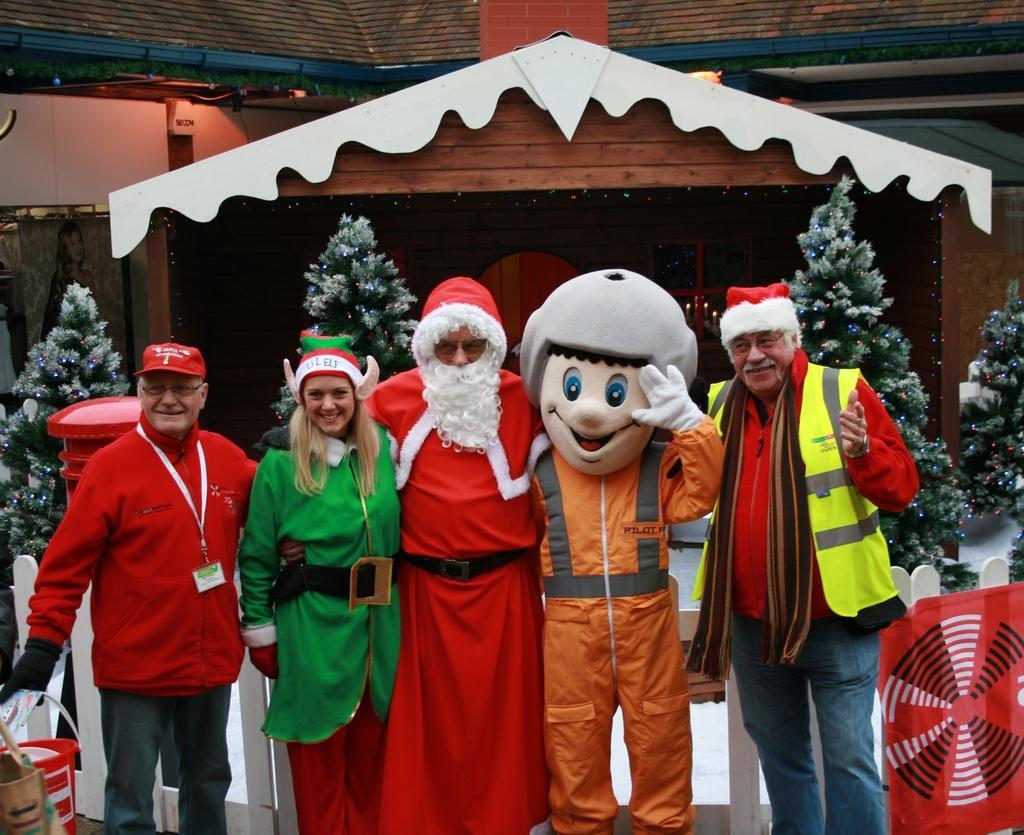Can you describe this image briefly? In the foreground I can see five persons are standing. Out of which two persons are wearing costumes and buckets. In the background I can see a fence, christmas trees, lights and a rooftop. This image is taken may be during a day. 